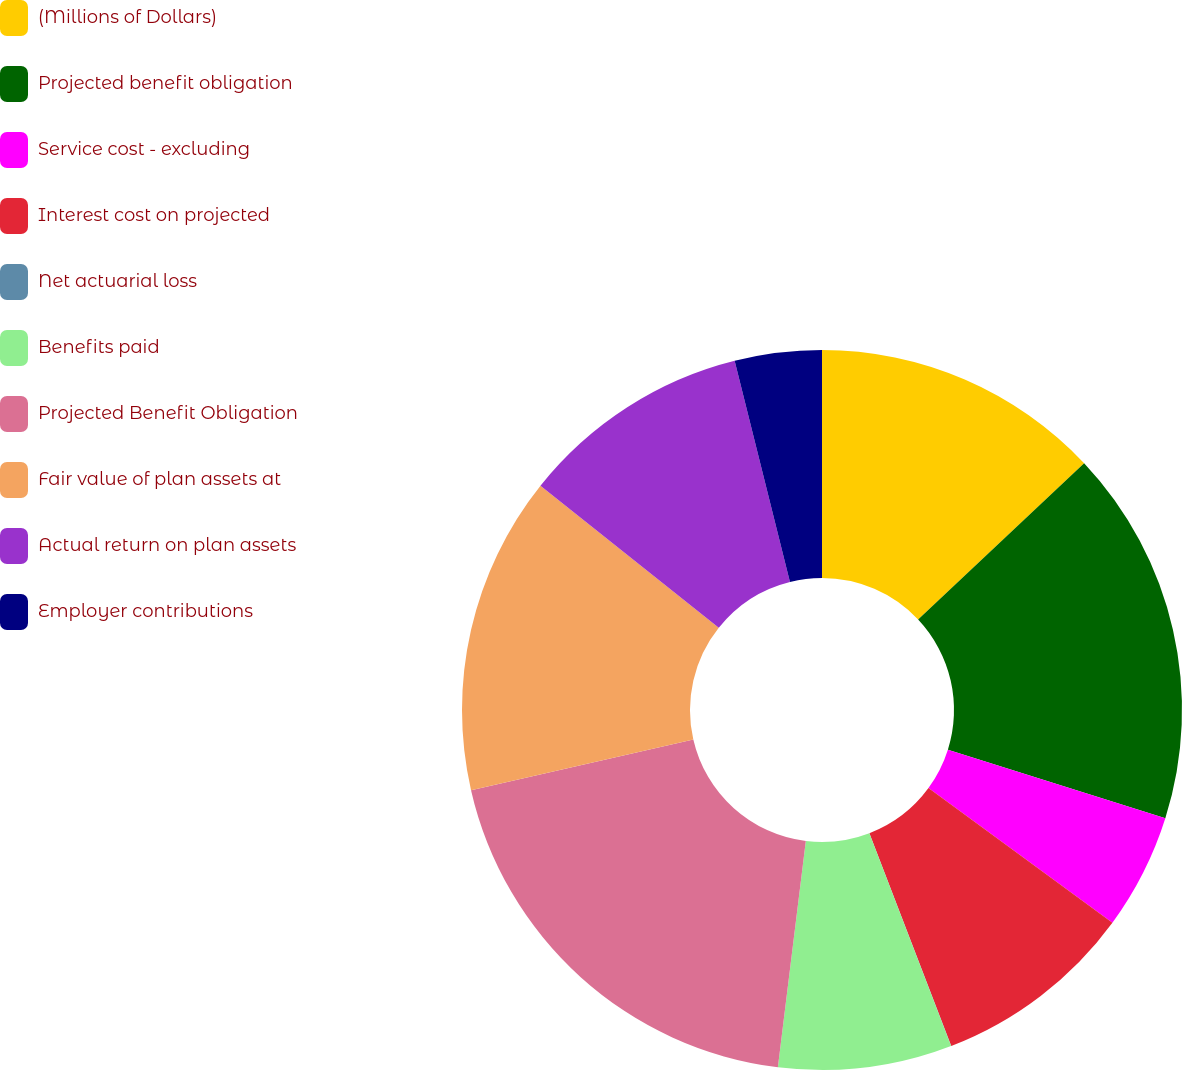<chart> <loc_0><loc_0><loc_500><loc_500><pie_chart><fcel>(Millions of Dollars)<fcel>Projected benefit obligation<fcel>Service cost - excluding<fcel>Interest cost on projected<fcel>Net actuarial loss<fcel>Benefits paid<fcel>Projected Benefit Obligation<fcel>Fair value of plan assets at<fcel>Actual return on plan assets<fcel>Employer contributions<nl><fcel>12.98%<fcel>16.88%<fcel>5.2%<fcel>9.09%<fcel>0.01%<fcel>7.79%<fcel>19.47%<fcel>14.28%<fcel>10.39%<fcel>3.9%<nl></chart> 